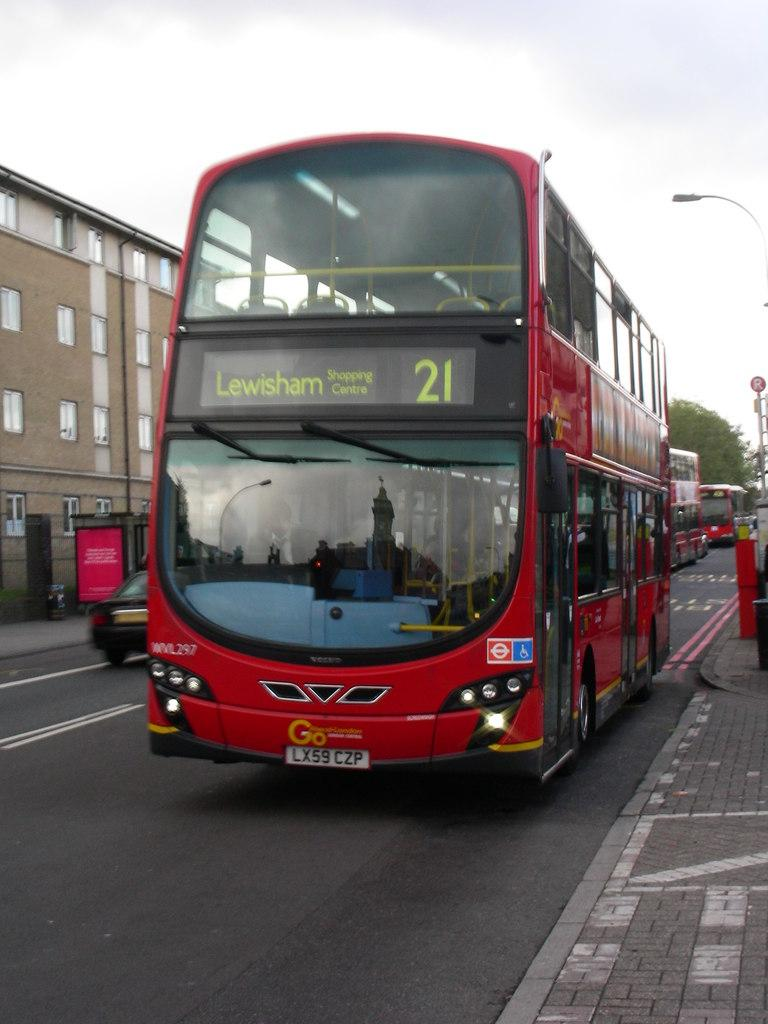<image>
Present a compact description of the photo's key features. A red double decker London bus going towards Lewisham. 